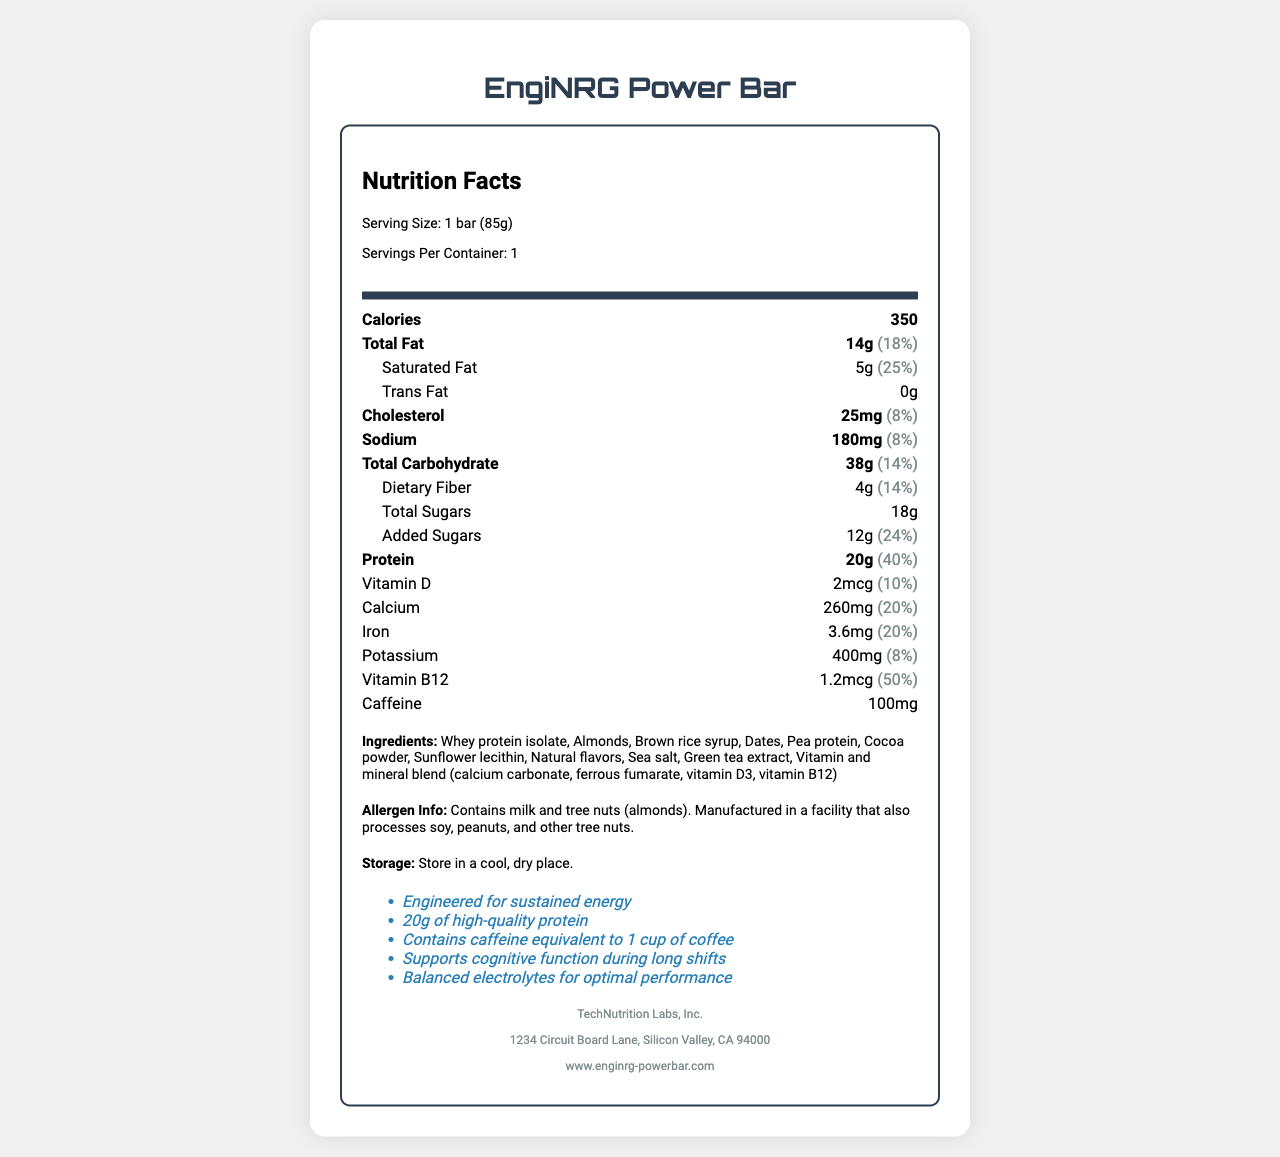How many calories are in one EngiNRG Power Bar? The document states that one serving size, which is equivalent to one bar, contains 350 calories.
Answer: 350 What is the total fat content in the EngiNRG Power Bar? The nutrition label under "Total Fat" specifies that there are 14 grams of total fat.
Answer: 14g What percentage of the daily value for protein does the EngiNRG Power Bar provide? The document under the protein section states that the bar provides 20 grams of protein, which is 40% of the daily value.
Answer: 40% How much caffeine is in the EngiNRG Power Bar? The nutrient row for caffeine lists the amount as 100mg.
Answer: 100mg Is there any trans fat in the EngiNRG Power Bar? The nutrient section for "Trans Fat" clearly shows that the amount is 0g.
Answer: No What is the amount of sodium in one serving of the EngiNRG Power Bar? The nutrient row for sodium indicates there are 180 milligrams per serving.
Answer: 180mg What are the first two ingredients listed on the EngiNRG Power Bar's label? A. Dates and Pea Protein B. Almonds and Brown Rice Syrup C. Whey Protein Isolate and Almonds The ingredient list of the document starts with "Whey protein isolate" followed by "Almonds."
Answer: C. Whey Protein Isolate and Almonds Which nutrient has the highest daily value percentage in the EngiNRG Power Bar? I. Total Fat II. Vitamin B12 III. Protein IV. Calcium The nutrient rows show that Vitamin B12 has a daily value of 50%, which is higher than the others listed.
Answer: II. Vitamin B12 Does the EngiNRG Power Bar contain any peanuts? The allergen information states that the bar contains milk and almonds and that it is manufactured in a facility that also processes peanuts and other tree nuts. This implies that peanuts are not an ingredient.
Answer: No Summarize the main features of the EngiNRG Power Bar as presented in the document. The document details the nutritional information, ingredients, allergen information, and claims about the EngiNRG Power Bar, highlighting its purpose for providing sustained energy and nutritional support during long shifts.
Answer: The EngiNRG Power Bar is high-energy, designed for engineers working long shifts. It contains 350 calories, 20 grams of protein, and 100 milligrams of caffeine. The bar provides various vitamins and minerals, including Vitamin D, calcium, iron, and Vitamin B12. Its ingredients include whey protein isolate, almonds, and natural flavors, and it contains common allergens like milk and tree nuts. The product claims to offer sustained energy, support cognitive function, and include balanced electrolytes. What is the main purpose of the EngiNRG Power Bar's formulation as per the claims? The claims listed in the document say that the bar is engineered for sustained energy and supports cognitive function during long shifts.
Answer: To provide sustained energy and support cognitive function during long shifts Can you determine the price of the EngiNRG Power Bar from the document? The document does not provide any information about the pricing of the EngiNRG Power Bar.
Answer: Cannot be determined 